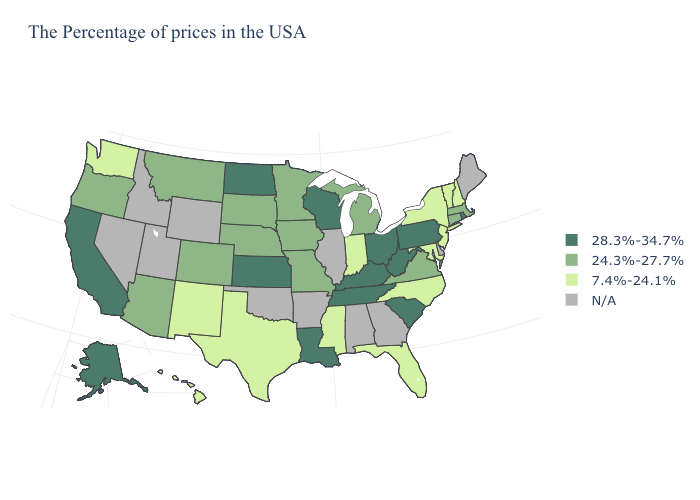Does the map have missing data?
Keep it brief. Yes. What is the value of West Virginia?
Concise answer only. 28.3%-34.7%. Name the states that have a value in the range 7.4%-24.1%?
Quick response, please. New Hampshire, Vermont, New York, New Jersey, Maryland, North Carolina, Florida, Indiana, Mississippi, Texas, New Mexico, Washington, Hawaii. Which states have the highest value in the USA?
Concise answer only. Rhode Island, Pennsylvania, South Carolina, West Virginia, Ohio, Kentucky, Tennessee, Wisconsin, Louisiana, Kansas, North Dakota, California, Alaska. Name the states that have a value in the range 7.4%-24.1%?
Be succinct. New Hampshire, Vermont, New York, New Jersey, Maryland, North Carolina, Florida, Indiana, Mississippi, Texas, New Mexico, Washington, Hawaii. Does Alaska have the highest value in the USA?
Short answer required. Yes. Among the states that border Ohio , does West Virginia have the lowest value?
Concise answer only. No. Name the states that have a value in the range 28.3%-34.7%?
Quick response, please. Rhode Island, Pennsylvania, South Carolina, West Virginia, Ohio, Kentucky, Tennessee, Wisconsin, Louisiana, Kansas, North Dakota, California, Alaska. What is the value of Wyoming?
Write a very short answer. N/A. What is the value of Tennessee?
Quick response, please. 28.3%-34.7%. Does the map have missing data?
Concise answer only. Yes. Is the legend a continuous bar?
Keep it brief. No. Does the map have missing data?
Short answer required. Yes. What is the highest value in the West ?
Give a very brief answer. 28.3%-34.7%. 